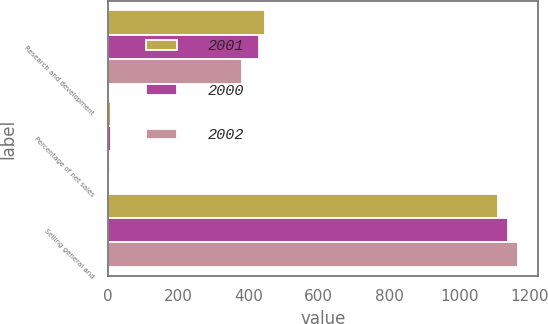Convert chart to OTSL. <chart><loc_0><loc_0><loc_500><loc_500><stacked_bar_chart><ecel><fcel>Research and development<fcel>Percentage of net sales<fcel>Selling general and<nl><fcel>2001<fcel>446<fcel>8<fcel>1111<nl><fcel>2000<fcel>430<fcel>8<fcel>1138<nl><fcel>2002<fcel>380<fcel>5<fcel>1166<nl></chart> 